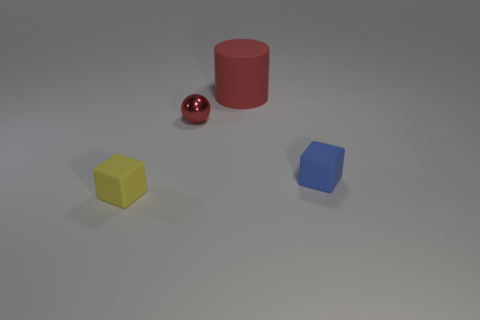What number of brown things are big cylinders or balls?
Your response must be concise. 0. Is there any other thing that is made of the same material as the blue cube?
Ensure brevity in your answer.  Yes. Is the material of the blue block in front of the cylinder the same as the ball?
Provide a succinct answer. No. How many objects are small red shiny spheres or tiny yellow rubber cubes that are left of the red cylinder?
Provide a short and direct response. 2. What number of objects are in front of the tiny cube left of the small matte object behind the tiny yellow rubber cube?
Make the answer very short. 0. Is the shape of the red object that is left of the large red matte cylinder the same as  the blue object?
Make the answer very short. No. Are there any metal objects that are behind the tiny thing right of the red matte thing?
Your answer should be very brief. Yes. What number of red metallic balls are there?
Provide a succinct answer. 1. The tiny object that is behind the small yellow matte object and to the left of the big red cylinder is what color?
Your response must be concise. Red. There is a yellow thing that is the same shape as the blue rubber object; what is its size?
Your answer should be very brief. Small. 